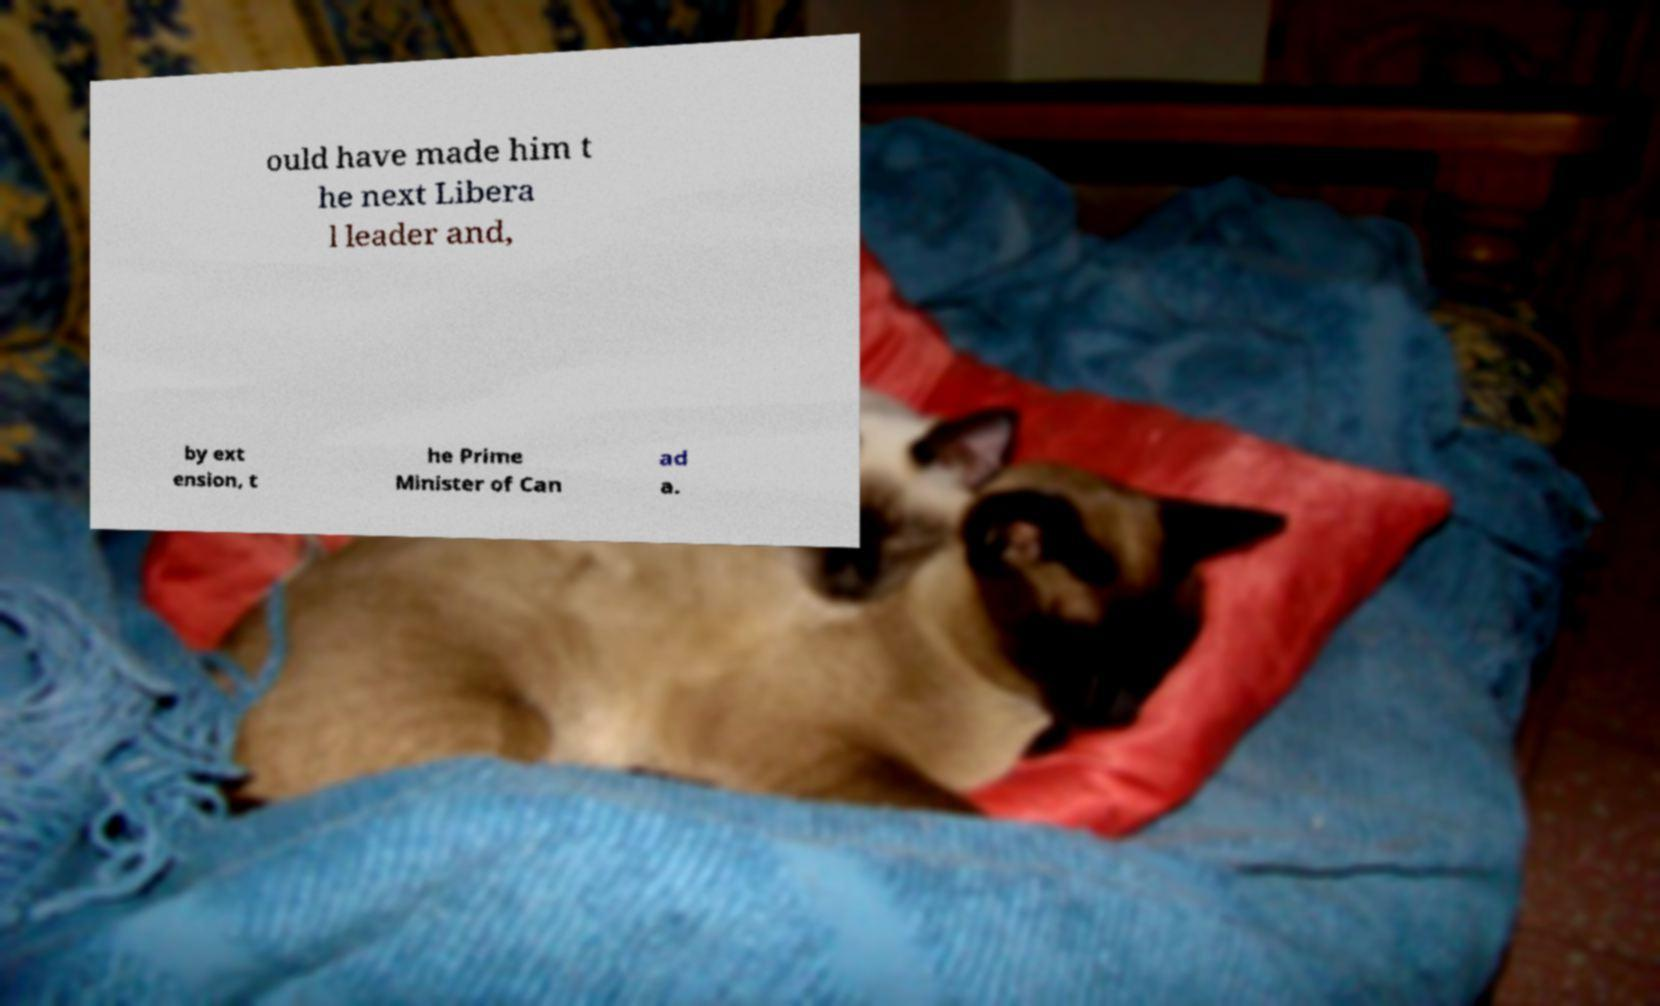There's text embedded in this image that I need extracted. Can you transcribe it verbatim? ould have made him t he next Libera l leader and, by ext ension, t he Prime Minister of Can ad a. 